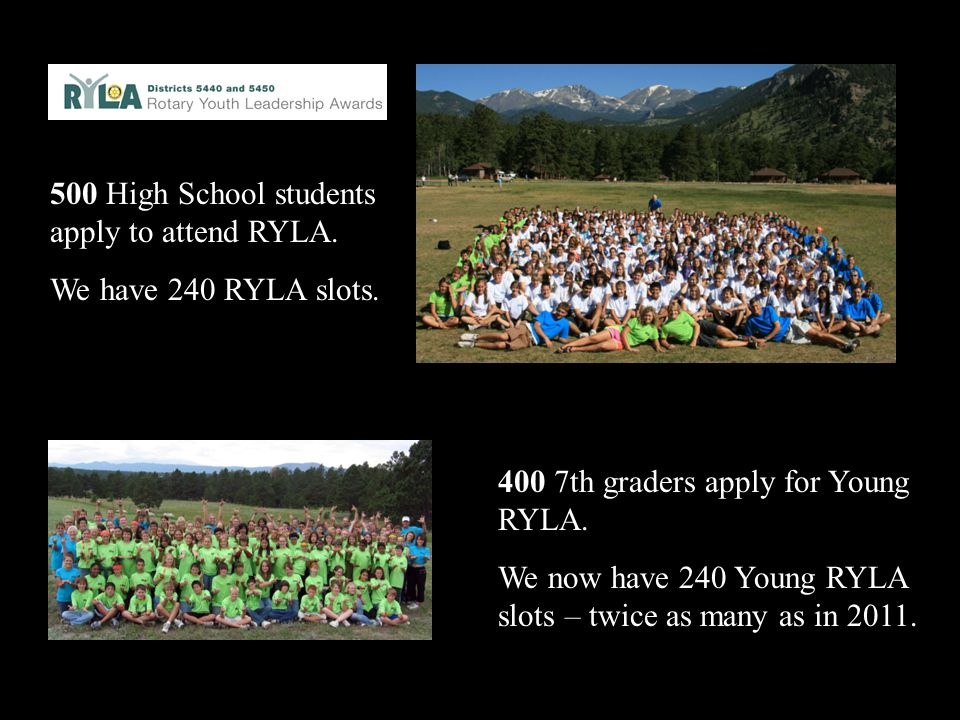Imagine a scenario where a participant at the Young RYLA camp discovers a new hobby or passion. What impact could this have on their personal and professional future? If a participant at the Young RYLA camp discovers a new hobby or passion, it could have a profound impact on their personal and professional future. Engaging in a new activity that they are passionate about can enhance their confidence and sense of purpose. For instance, discovering a love for public speaking or community service could steer them towards leadership roles in school, community organizations, or even their future career. Passionate pursuits can also provide a productive outlet for creativity and stress relief, contributing to overall well-being. The skills and experiences gained from following a new hobby can build resilience, adaptability, and a network of like-minded individuals, all of which are beneficial for personal growth and professional opportunities.  What if the camp organizers decided to introduce a new technology-based leadership activity? How could this benefit the participants? Introducing a technology-based leadership activity could greatly benefit participants by equipping them with critical digital skills that are increasingly important in today's world. Activities such as coding workshops, digital project management tasks, or virtual team collaborations can enhance their technical proficiency and understanding of modern tools and platforms. These skills are valuable in nearly every career field and can give participants a competitive edge in the job market. Additionally, technology-based activities can teach problem-solving, creativity, and adaptability. Learning to lead and collaborate in a digital environment mirrors many real-world professional settings, preparing the participants for future challenges and opportunities. 